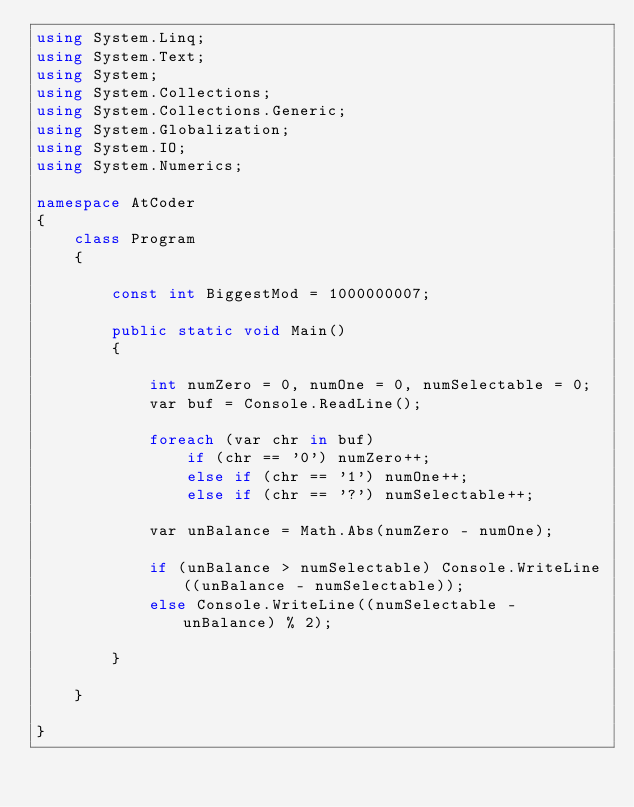<code> <loc_0><loc_0><loc_500><loc_500><_C#_>using System.Linq;
using System.Text;
using System;
using System.Collections;
using System.Collections.Generic;
using System.Globalization;
using System.IO;
using System.Numerics;

namespace AtCoder
{
    class Program
    {

        const int BiggestMod = 1000000007;

        public static void Main()
        {

            int numZero = 0, numOne = 0, numSelectable = 0;
            var buf = Console.ReadLine();

            foreach (var chr in buf)
                if (chr == '0') numZero++;
                else if (chr == '1') numOne++;
                else if (chr == '?') numSelectable++;

            var unBalance = Math.Abs(numZero - numOne);

            if (unBalance > numSelectable) Console.WriteLine((unBalance - numSelectable));
            else Console.WriteLine((numSelectable - unBalance) % 2);
            
        }

    }

}
</code> 